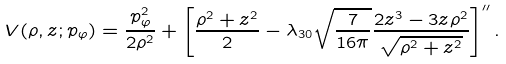<formula> <loc_0><loc_0><loc_500><loc_500>V ( \rho , z ; p _ { \varphi } ) = \frac { p _ { \varphi } ^ { 2 } } { 2 \rho ^ { 2 } } + \left [ \frac { \rho ^ { 2 } + z ^ { 2 } } { 2 } - \lambda _ { 3 0 } \sqrt { \frac { 7 } { 1 6 \pi } } \frac { 2 z ^ { 3 } - 3 z \rho ^ { 2 } } { \sqrt { \rho ^ { 2 } + z ^ { 2 } } } \right ] ^ { \prime \prime } .</formula> 